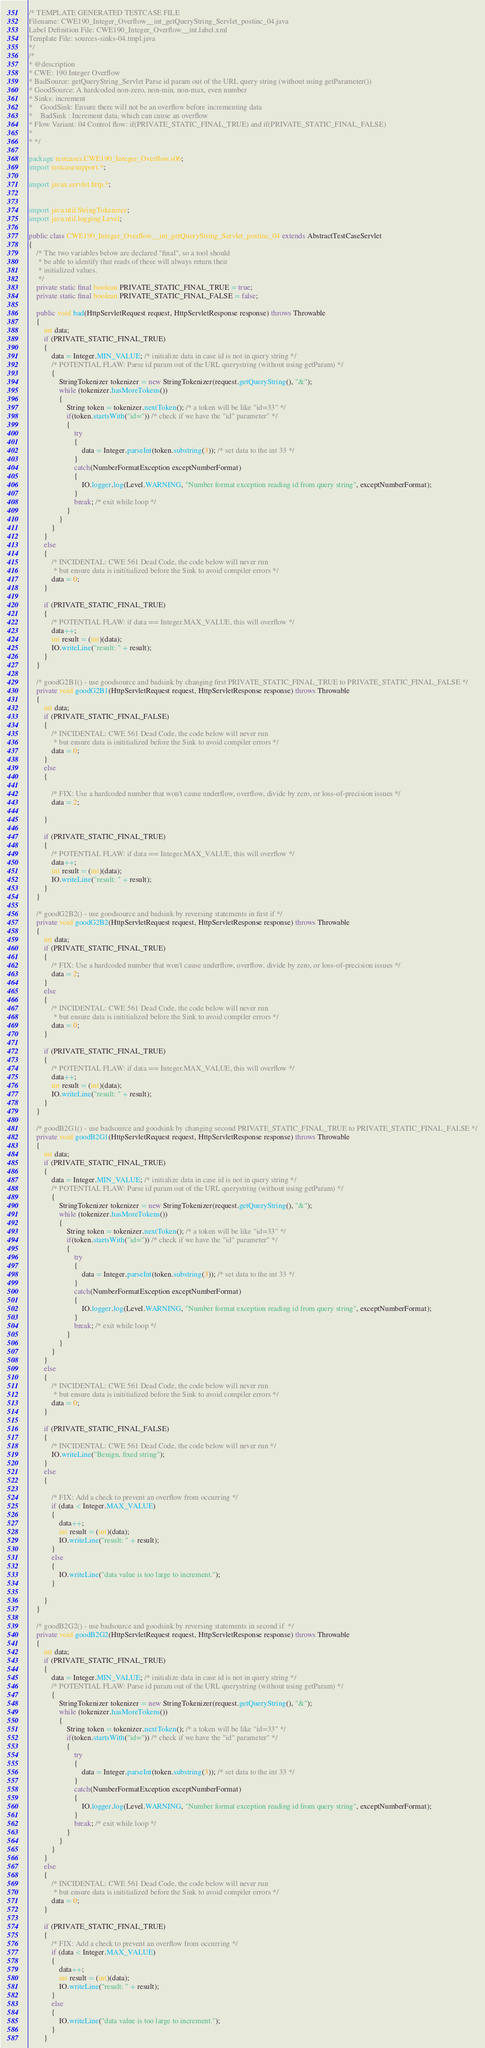Convert code to text. <code><loc_0><loc_0><loc_500><loc_500><_Java_>/* TEMPLATE GENERATED TESTCASE FILE
Filename: CWE190_Integer_Overflow__int_getQueryString_Servlet_postinc_04.java
Label Definition File: CWE190_Integer_Overflow__int.label.xml
Template File: sources-sinks-04.tmpl.java
*/
/*
* @description
* CWE: 190 Integer Overflow
* BadSource: getQueryString_Servlet Parse id param out of the URL query string (without using getParameter())
* GoodSource: A hardcoded non-zero, non-min, non-max, even number
* Sinks: increment
*    GoodSink: Ensure there will not be an overflow before incrementing data
*    BadSink : Increment data, which can cause an overflow
* Flow Variant: 04 Control flow: if(PRIVATE_STATIC_FINAL_TRUE) and if(PRIVATE_STATIC_FINAL_FALSE)
*
* */

package testcases.CWE190_Integer_Overflow.s06;
import testcasesupport.*;

import javax.servlet.http.*;


import java.util.StringTokenizer;
import java.util.logging.Level;

public class CWE190_Integer_Overflow__int_getQueryString_Servlet_postinc_04 extends AbstractTestCaseServlet
{
    /* The two variables below are declared "final", so a tool should
     * be able to identify that reads of these will always return their
     * initialized values.
     */
    private static final boolean PRIVATE_STATIC_FINAL_TRUE = true;
    private static final boolean PRIVATE_STATIC_FINAL_FALSE = false;

    public void bad(HttpServletRequest request, HttpServletResponse response) throws Throwable
    {
        int data;
        if (PRIVATE_STATIC_FINAL_TRUE)
        {
            data = Integer.MIN_VALUE; /* initialize data in case id is not in query string */
            /* POTENTIAL FLAW: Parse id param out of the URL querystring (without using getParam) */
            {
                StringTokenizer tokenizer = new StringTokenizer(request.getQueryString(), "&");
                while (tokenizer.hasMoreTokens())
                {
                    String token = tokenizer.nextToken(); /* a token will be like "id=33" */
                    if(token.startsWith("id=")) /* check if we have the "id" parameter" */
                    {
                        try
                        {
                            data = Integer.parseInt(token.substring(3)); /* set data to the int 33 */
                        }
                        catch(NumberFormatException exceptNumberFormat)
                        {
                            IO.logger.log(Level.WARNING, "Number format exception reading id from query string", exceptNumberFormat);
                        }
                        break; /* exit while loop */
                    }
                }
            }
        }
        else
        {
            /* INCIDENTAL: CWE 561 Dead Code, the code below will never run
             * but ensure data is inititialized before the Sink to avoid compiler errors */
            data = 0;
        }

        if (PRIVATE_STATIC_FINAL_TRUE)
        {
            /* POTENTIAL FLAW: if data == Integer.MAX_VALUE, this will overflow */
            data++;
            int result = (int)(data);
            IO.writeLine("result: " + result);
        }
    }

    /* goodG2B1() - use goodsource and badsink by changing first PRIVATE_STATIC_FINAL_TRUE to PRIVATE_STATIC_FINAL_FALSE */
    private void goodG2B1(HttpServletRequest request, HttpServletResponse response) throws Throwable
    {
        int data;
        if (PRIVATE_STATIC_FINAL_FALSE)
        {
            /* INCIDENTAL: CWE 561 Dead Code, the code below will never run
             * but ensure data is inititialized before the Sink to avoid compiler errors */
            data = 0;
        }
        else
        {

            /* FIX: Use a hardcoded number that won't cause underflow, overflow, divide by zero, or loss-of-precision issues */
            data = 2;

        }

        if (PRIVATE_STATIC_FINAL_TRUE)
        {
            /* POTENTIAL FLAW: if data == Integer.MAX_VALUE, this will overflow */
            data++;
            int result = (int)(data);
            IO.writeLine("result: " + result);
        }
    }

    /* goodG2B2() - use goodsource and badsink by reversing statements in first if */
    private void goodG2B2(HttpServletRequest request, HttpServletResponse response) throws Throwable
    {
        int data;
        if (PRIVATE_STATIC_FINAL_TRUE)
        {
            /* FIX: Use a hardcoded number that won't cause underflow, overflow, divide by zero, or loss-of-precision issues */
            data = 2;
        }
        else
        {
            /* INCIDENTAL: CWE 561 Dead Code, the code below will never run
             * but ensure data is inititialized before the Sink to avoid compiler errors */
            data = 0;
        }

        if (PRIVATE_STATIC_FINAL_TRUE)
        {
            /* POTENTIAL FLAW: if data == Integer.MAX_VALUE, this will overflow */
            data++;
            int result = (int)(data);
            IO.writeLine("result: " + result);
        }
    }

    /* goodB2G1() - use badsource and goodsink by changing second PRIVATE_STATIC_FINAL_TRUE to PRIVATE_STATIC_FINAL_FALSE */
    private void goodB2G1(HttpServletRequest request, HttpServletResponse response) throws Throwable
    {
        int data;
        if (PRIVATE_STATIC_FINAL_TRUE)
        {
            data = Integer.MIN_VALUE; /* initialize data in case id is not in query string */
            /* POTENTIAL FLAW: Parse id param out of the URL querystring (without using getParam) */
            {
                StringTokenizer tokenizer = new StringTokenizer(request.getQueryString(), "&");
                while (tokenizer.hasMoreTokens())
                {
                    String token = tokenizer.nextToken(); /* a token will be like "id=33" */
                    if(token.startsWith("id=")) /* check if we have the "id" parameter" */
                    {
                        try
                        {
                            data = Integer.parseInt(token.substring(3)); /* set data to the int 33 */
                        }
                        catch(NumberFormatException exceptNumberFormat)
                        {
                            IO.logger.log(Level.WARNING, "Number format exception reading id from query string", exceptNumberFormat);
                        }
                        break; /* exit while loop */
                    }
                }
            }
        }
        else
        {
            /* INCIDENTAL: CWE 561 Dead Code, the code below will never run
             * but ensure data is inititialized before the Sink to avoid compiler errors */
            data = 0;
        }

        if (PRIVATE_STATIC_FINAL_FALSE)
        {
            /* INCIDENTAL: CWE 561 Dead Code, the code below will never run */
            IO.writeLine("Benign, fixed string");
        }
        else
        {

            /* FIX: Add a check to prevent an overflow from occurring */
            if (data < Integer.MAX_VALUE)
            {
                data++;
                int result = (int)(data);
                IO.writeLine("result: " + result);
            }
            else
            {
                IO.writeLine("data value is too large to increment.");
            }

        }
    }

    /* goodB2G2() - use badsource and goodsink by reversing statements in second if  */
    private void goodB2G2(HttpServletRequest request, HttpServletResponse response) throws Throwable
    {
        int data;
        if (PRIVATE_STATIC_FINAL_TRUE)
        {
            data = Integer.MIN_VALUE; /* initialize data in case id is not in query string */
            /* POTENTIAL FLAW: Parse id param out of the URL querystring (without using getParam) */
            {
                StringTokenizer tokenizer = new StringTokenizer(request.getQueryString(), "&");
                while (tokenizer.hasMoreTokens())
                {
                    String token = tokenizer.nextToken(); /* a token will be like "id=33" */
                    if(token.startsWith("id=")) /* check if we have the "id" parameter" */
                    {
                        try
                        {
                            data = Integer.parseInt(token.substring(3)); /* set data to the int 33 */
                        }
                        catch(NumberFormatException exceptNumberFormat)
                        {
                            IO.logger.log(Level.WARNING, "Number format exception reading id from query string", exceptNumberFormat);
                        }
                        break; /* exit while loop */
                    }
                }
            }
        }
        else
        {
            /* INCIDENTAL: CWE 561 Dead Code, the code below will never run
             * but ensure data is inititialized before the Sink to avoid compiler errors */
            data = 0;
        }

        if (PRIVATE_STATIC_FINAL_TRUE)
        {
            /* FIX: Add a check to prevent an overflow from occurring */
            if (data < Integer.MAX_VALUE)
            {
                data++;
                int result = (int)(data);
                IO.writeLine("result: " + result);
            }
            else
            {
                IO.writeLine("data value is too large to increment.");
            }
        }</code> 